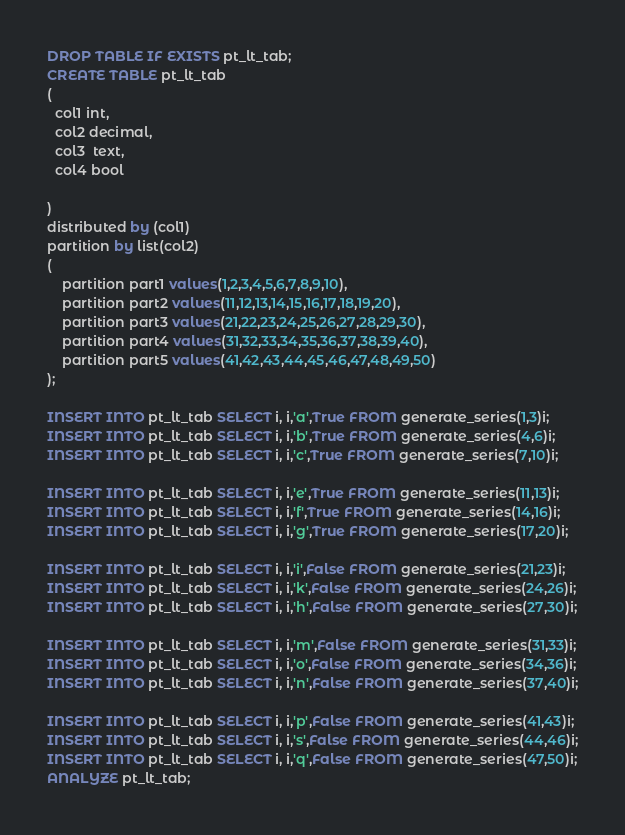<code> <loc_0><loc_0><loc_500><loc_500><_SQL_>DROP TABLE IF EXISTS pt_lt_tab;
CREATE TABLE pt_lt_tab
(
  col1 int,
  col2 decimal,
  col3  text,
  col4 bool
  
)
distributed by (col1)
partition by list(col2)
(
	partition part1 values(1,2,3,4,5,6,7,8,9,10),
	partition part2 values(11,12,13,14,15,16,17,18,19,20),
	partition part3 values(21,22,23,24,25,26,27,28,29,30),
	partition part4 values(31,32,33,34,35,36,37,38,39,40),
	partition part5 values(41,42,43,44,45,46,47,48,49,50)
);

INSERT INTO pt_lt_tab SELECT i, i,'a',True FROM generate_series(1,3)i;
INSERT INTO pt_lt_tab SELECT i, i,'b',True FROM generate_series(4,6)i;
INSERT INTO pt_lt_tab SELECT i, i,'c',True FROM generate_series(7,10)i;

INSERT INTO pt_lt_tab SELECT i, i,'e',True FROM generate_series(11,13)i;
INSERT INTO pt_lt_tab SELECT i, i,'f',True FROM generate_series(14,16)i;
INSERT INTO pt_lt_tab SELECT i, i,'g',True FROM generate_series(17,20)i;

INSERT INTO pt_lt_tab SELECT i, i,'i',False FROM generate_series(21,23)i;
INSERT INTO pt_lt_tab SELECT i, i,'k',False FROM generate_series(24,26)i;
INSERT INTO pt_lt_tab SELECT i, i,'h',False FROM generate_series(27,30)i;

INSERT INTO pt_lt_tab SELECT i, i,'m',False FROM generate_series(31,33)i;
INSERT INTO pt_lt_tab SELECT i, i,'o',False FROM generate_series(34,36)i;
INSERT INTO pt_lt_tab SELECT i, i,'n',False FROM generate_series(37,40)i;

INSERT INTO pt_lt_tab SELECT i, i,'p',False FROM generate_series(41,43)i;
INSERT INTO pt_lt_tab SELECT i, i,'s',False FROM generate_series(44,46)i;
INSERT INTO pt_lt_tab SELECT i, i,'q',False FROM generate_series(47,50)i;
ANALYZE pt_lt_tab;
</code> 